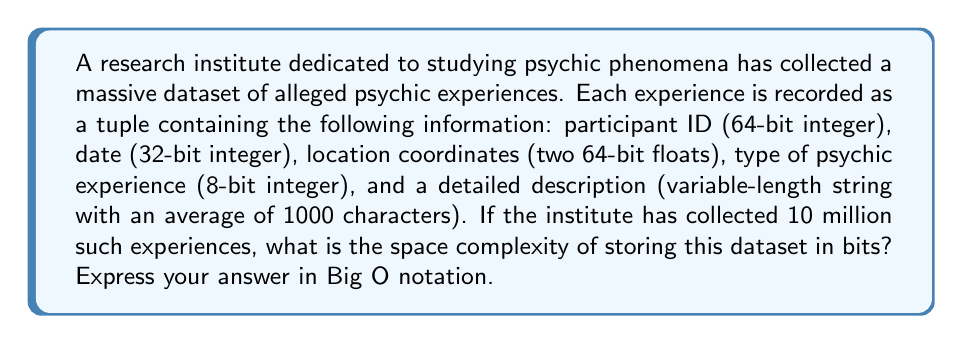Show me your answer to this math problem. To calculate the space complexity, we need to sum up the space required for each component of the tuple and then multiply by the number of experiences:

1. Participant ID: 64 bits
2. Date: 32 bits
3. Location coordinates: 2 * 64 = 128 bits
4. Type of psychic experience: 8 bits
5. Detailed description: 1000 characters * 8 bits/character = 8000 bits

Total bits per experience:
$$ 64 + 32 + 128 + 8 + 8000 = 8232 \text{ bits} $$

For 10 million experiences:
$$ 8232 \text{ bits} \times 10^7 = 82.32 \times 10^9 \text{ bits} $$

In Big O notation, we express this as $O(n)$, where $n$ is the number of experiences. This is because the space required grows linearly with the number of experiences.

The constant factors and lower-order terms are dropped in Big O notation, so even though we have a large constant (8232), it doesn't affect the overall complexity.
Answer: $O(n)$, where $n$ is the number of psychic experiences recorded. 